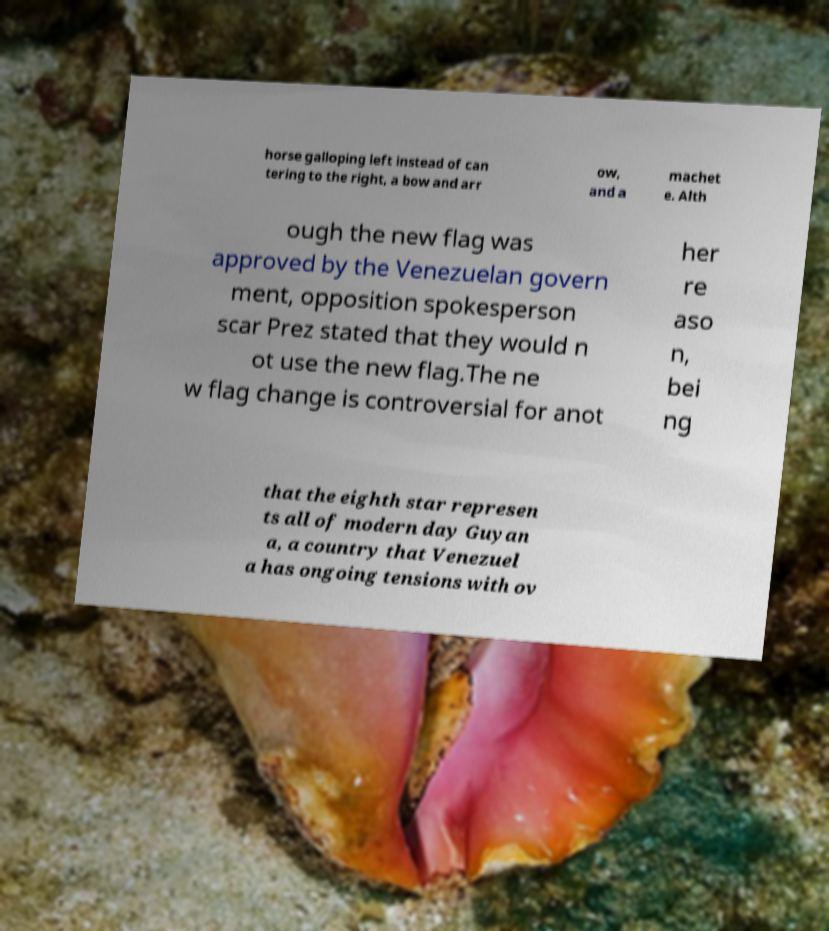For documentation purposes, I need the text within this image transcribed. Could you provide that? horse galloping left instead of can tering to the right, a bow and arr ow, and a machet e. Alth ough the new flag was approved by the Venezuelan govern ment, opposition spokesperson scar Prez stated that they would n ot use the new flag.The ne w flag change is controversial for anot her re aso n, bei ng that the eighth star represen ts all of modern day Guyan a, a country that Venezuel a has ongoing tensions with ov 